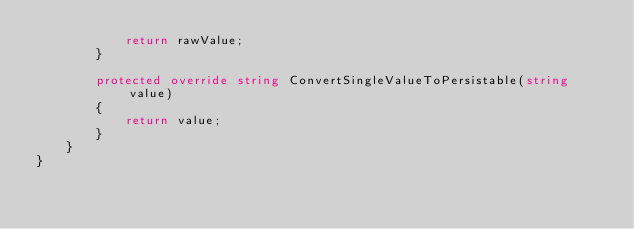Convert code to text. <code><loc_0><loc_0><loc_500><loc_500><_C#_>            return rawValue;
        }

        protected override string ConvertSingleValueToPersistable(string value)
        {
            return value;
        }
    }
}</code> 